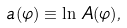<formula> <loc_0><loc_0><loc_500><loc_500>a ( \varphi ) \equiv \ln \, A ( \varphi ) ,</formula> 